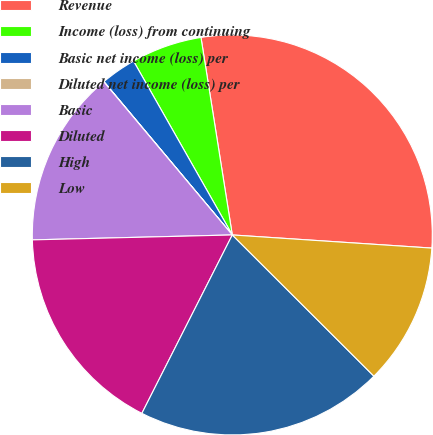Convert chart to OTSL. <chart><loc_0><loc_0><loc_500><loc_500><pie_chart><fcel>Revenue<fcel>Income (loss) from continuing<fcel>Basic net income (loss) per<fcel>Diluted net income (loss) per<fcel>Basic<fcel>Diluted<fcel>High<fcel>Low<nl><fcel>28.55%<fcel>5.72%<fcel>2.87%<fcel>0.02%<fcel>14.28%<fcel>17.14%<fcel>19.99%<fcel>11.43%<nl></chart> 